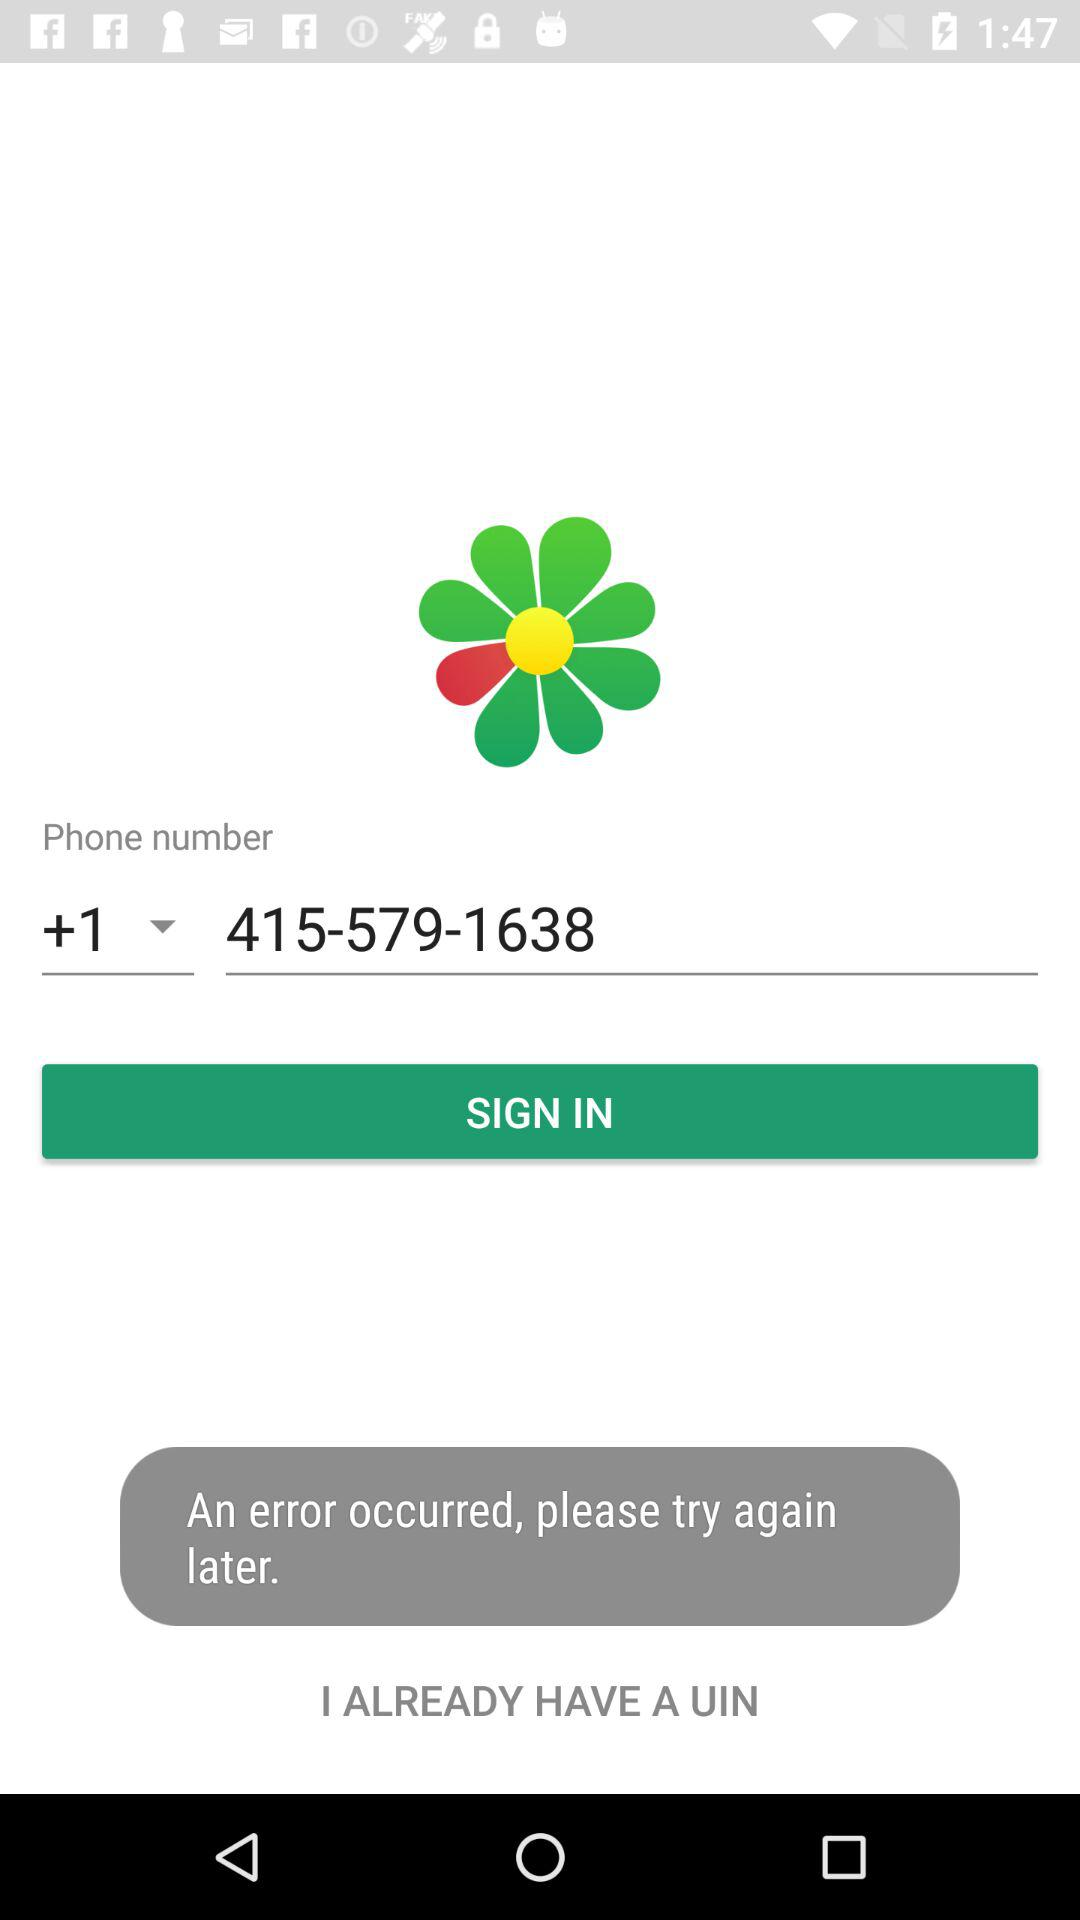What is the country's code? The country's code is +1. 